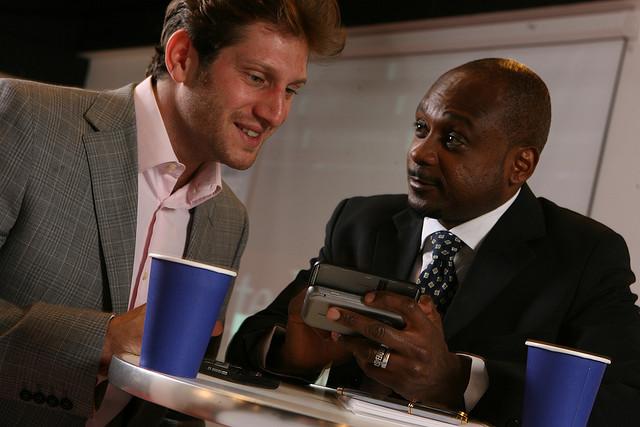Is the man wearing glasses?
Be succinct. No. Does this person have on a necktie?
Be succinct. Yes. How many men are wearing ties?
Quick response, please. 1. Who is speaking here?
Answer briefly. Two men. Are the men wearing tee shirts?
Short answer required. No. What are the old men looking at?
Write a very short answer. Phone. What are the gentlemen holding?
Write a very short answer. Phone. What is the man holding?
Write a very short answer. Phone. What color are the cups?
Answer briefly. Blue. 